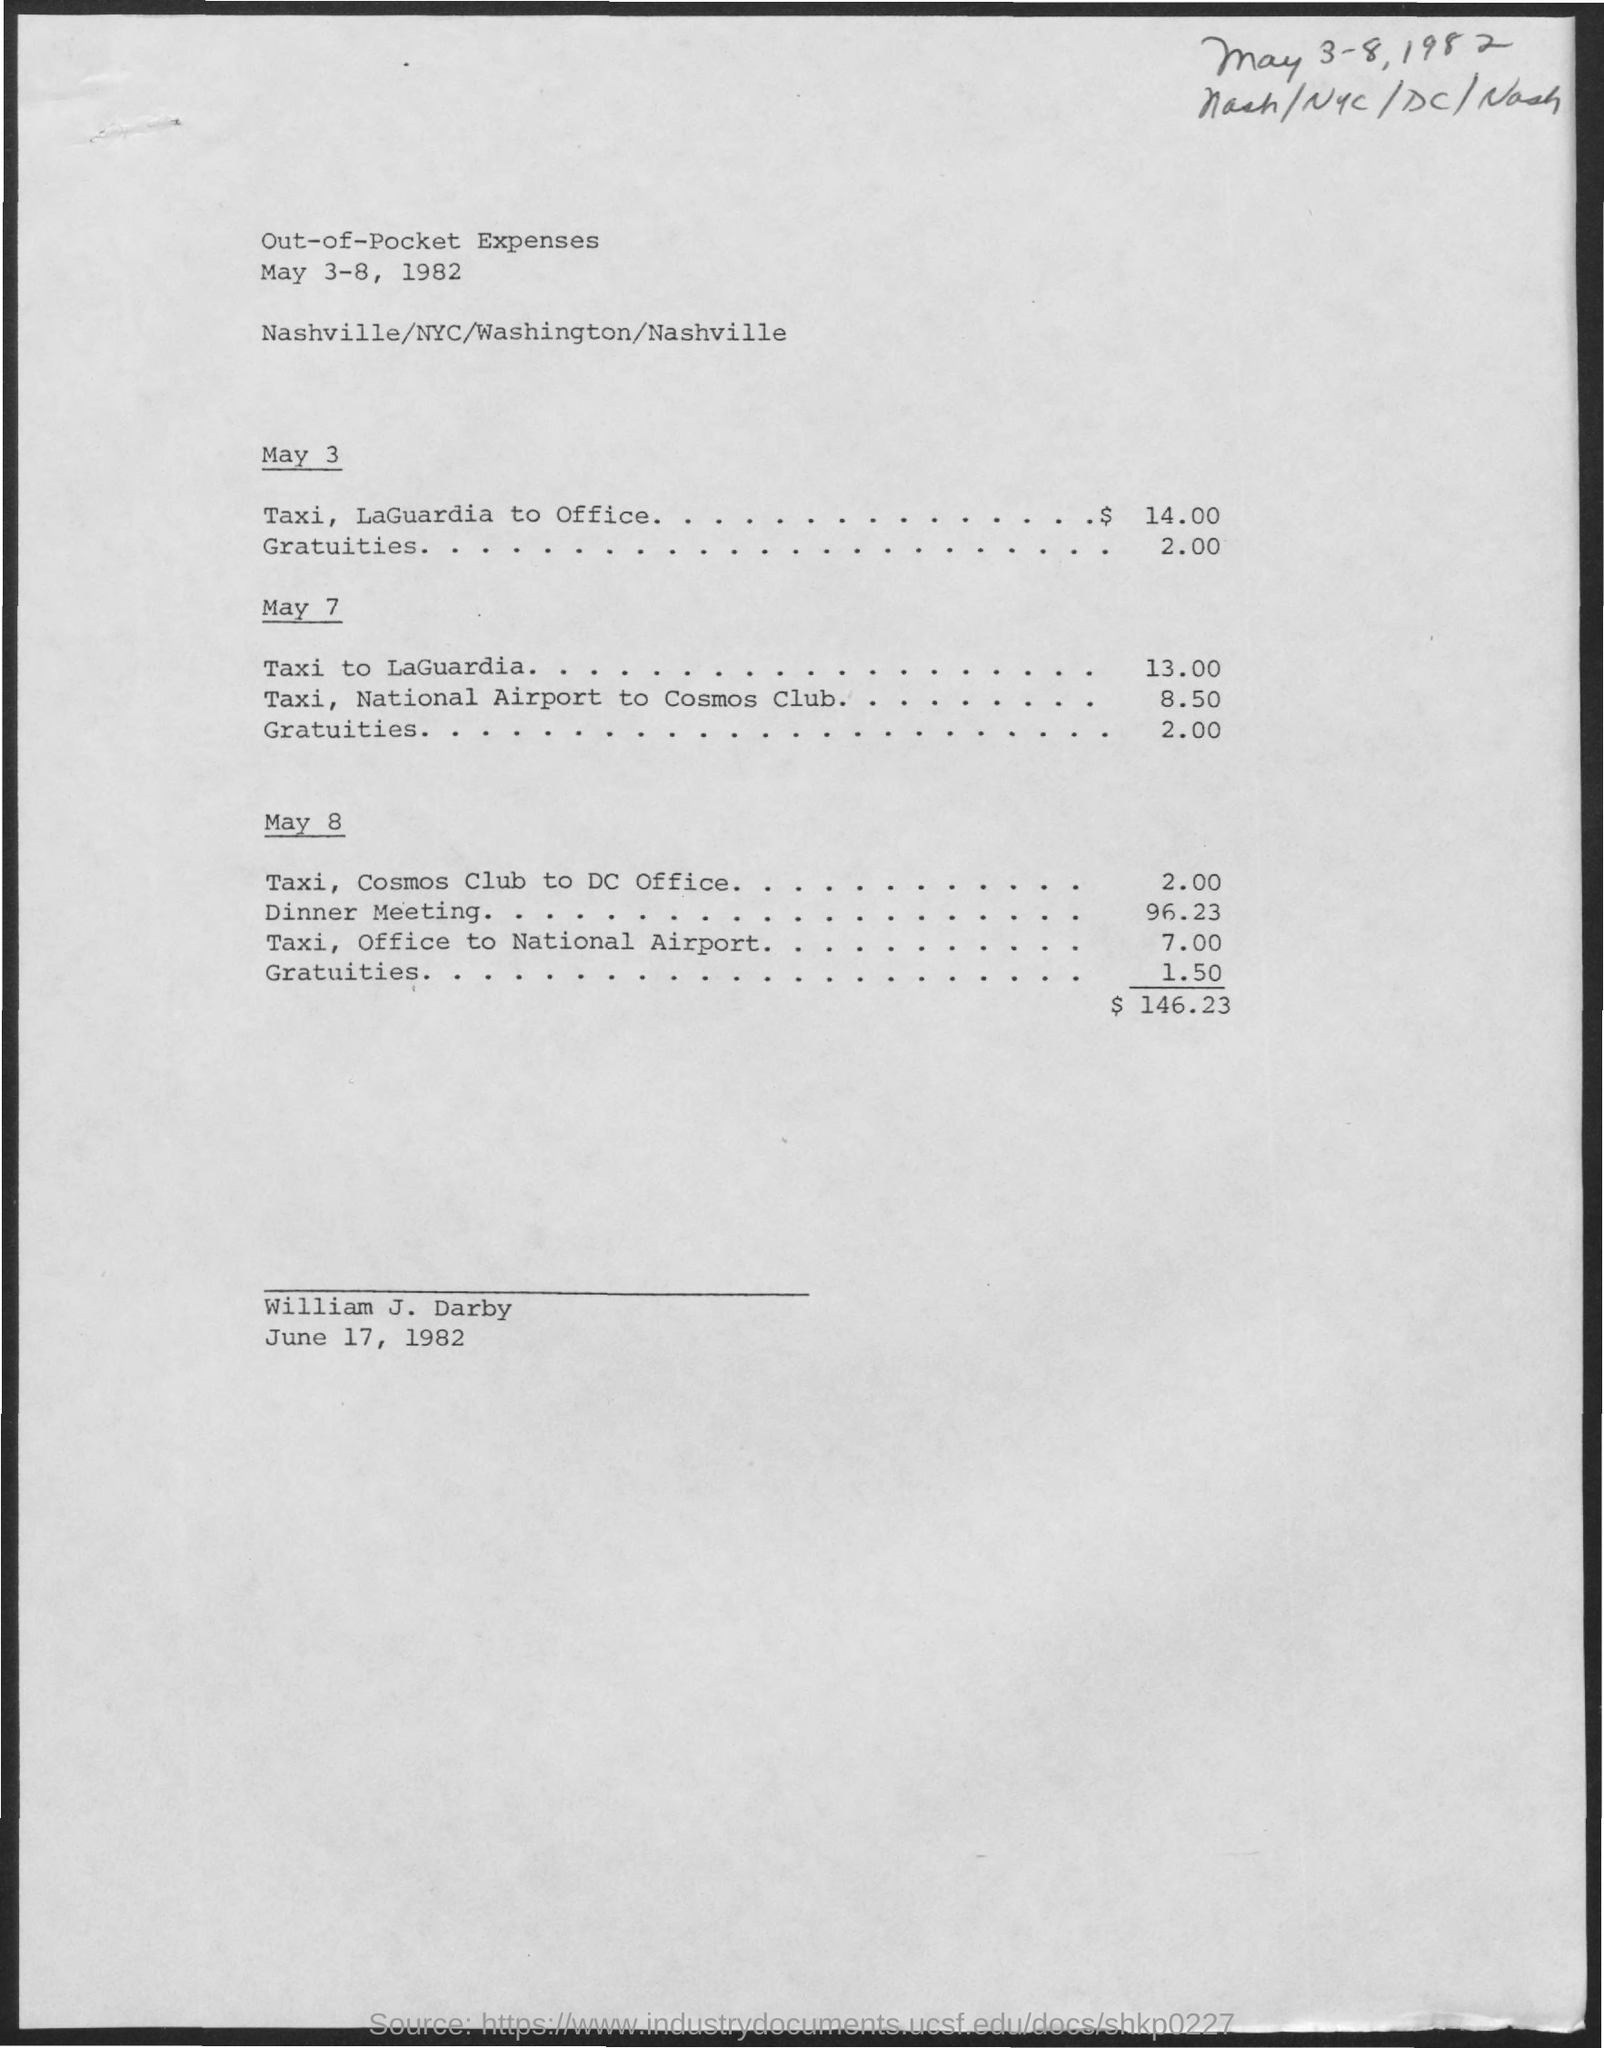What is the date mentioned at the bottom of the document?
Offer a very short reply. June 17, 1982. What is the name of the person mentioned in the document?
Your answer should be very brief. William j. darby. What is the taxi fare from the National airport to the Cosmos club on May 7?
Keep it short and to the point. 8.50. What is the taxi fare from the Cosmos club to DC Office on May 8?
Ensure brevity in your answer.  2.00. What is the taxi fare from the Office to the National Airport on May 8?
Your answer should be very brief. 7.00. 